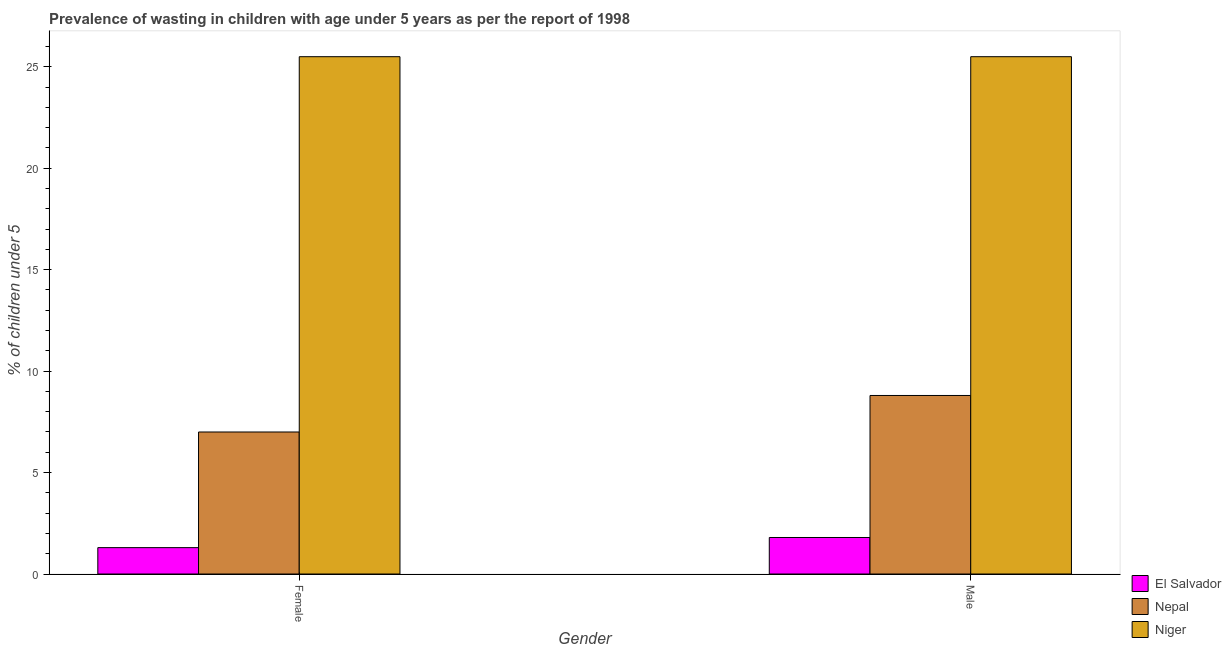How many different coloured bars are there?
Offer a very short reply. 3. How many bars are there on the 2nd tick from the left?
Ensure brevity in your answer.  3. How many bars are there on the 1st tick from the right?
Keep it short and to the point. 3. Across all countries, what is the minimum percentage of undernourished male children?
Make the answer very short. 1.8. In which country was the percentage of undernourished female children maximum?
Offer a terse response. Niger. In which country was the percentage of undernourished female children minimum?
Keep it short and to the point. El Salvador. What is the total percentage of undernourished male children in the graph?
Provide a succinct answer. 36.1. What is the difference between the percentage of undernourished female children in Nepal and that in El Salvador?
Give a very brief answer. 5.7. What is the difference between the percentage of undernourished female children in Niger and the percentage of undernourished male children in El Salvador?
Provide a succinct answer. 23.7. What is the average percentage of undernourished female children per country?
Keep it short and to the point. 11.27. What is the difference between the percentage of undernourished female children and percentage of undernourished male children in Nepal?
Keep it short and to the point. -1.8. What is the ratio of the percentage of undernourished male children in Niger to that in El Salvador?
Ensure brevity in your answer.  14.17. In how many countries, is the percentage of undernourished female children greater than the average percentage of undernourished female children taken over all countries?
Keep it short and to the point. 1. What does the 2nd bar from the left in Female represents?
Offer a terse response. Nepal. What does the 3rd bar from the right in Female represents?
Give a very brief answer. El Salvador. Are all the bars in the graph horizontal?
Offer a terse response. No. How many countries are there in the graph?
Keep it short and to the point. 3. Are the values on the major ticks of Y-axis written in scientific E-notation?
Ensure brevity in your answer.  No. How many legend labels are there?
Make the answer very short. 3. How are the legend labels stacked?
Your response must be concise. Vertical. What is the title of the graph?
Keep it short and to the point. Prevalence of wasting in children with age under 5 years as per the report of 1998. What is the label or title of the Y-axis?
Your answer should be compact.  % of children under 5. What is the  % of children under 5 in El Salvador in Female?
Your answer should be compact. 1.3. What is the  % of children under 5 in Nepal in Female?
Provide a short and direct response. 7. What is the  % of children under 5 in El Salvador in Male?
Make the answer very short. 1.8. What is the  % of children under 5 in Nepal in Male?
Your answer should be compact. 8.8. What is the  % of children under 5 of Niger in Male?
Give a very brief answer. 25.5. Across all Gender, what is the maximum  % of children under 5 of El Salvador?
Provide a short and direct response. 1.8. Across all Gender, what is the maximum  % of children under 5 in Nepal?
Give a very brief answer. 8.8. Across all Gender, what is the minimum  % of children under 5 of El Salvador?
Make the answer very short. 1.3. What is the difference between the  % of children under 5 in El Salvador in Female and the  % of children under 5 in Niger in Male?
Ensure brevity in your answer.  -24.2. What is the difference between the  % of children under 5 of Nepal in Female and the  % of children under 5 of Niger in Male?
Your response must be concise. -18.5. What is the average  % of children under 5 of El Salvador per Gender?
Your answer should be compact. 1.55. What is the average  % of children under 5 of Nepal per Gender?
Give a very brief answer. 7.9. What is the difference between the  % of children under 5 of El Salvador and  % of children under 5 of Niger in Female?
Your answer should be very brief. -24.2. What is the difference between the  % of children under 5 in Nepal and  % of children under 5 in Niger in Female?
Offer a terse response. -18.5. What is the difference between the  % of children under 5 of El Salvador and  % of children under 5 of Nepal in Male?
Ensure brevity in your answer.  -7. What is the difference between the  % of children under 5 in El Salvador and  % of children under 5 in Niger in Male?
Make the answer very short. -23.7. What is the difference between the  % of children under 5 of Nepal and  % of children under 5 of Niger in Male?
Provide a short and direct response. -16.7. What is the ratio of the  % of children under 5 in El Salvador in Female to that in Male?
Ensure brevity in your answer.  0.72. What is the ratio of the  % of children under 5 of Nepal in Female to that in Male?
Offer a terse response. 0.8. What is the ratio of the  % of children under 5 in Niger in Female to that in Male?
Your answer should be very brief. 1. What is the difference between the highest and the second highest  % of children under 5 of El Salvador?
Offer a very short reply. 0.5. What is the difference between the highest and the second highest  % of children under 5 in Nepal?
Offer a terse response. 1.8. What is the difference between the highest and the lowest  % of children under 5 of Nepal?
Give a very brief answer. 1.8. What is the difference between the highest and the lowest  % of children under 5 of Niger?
Provide a short and direct response. 0. 